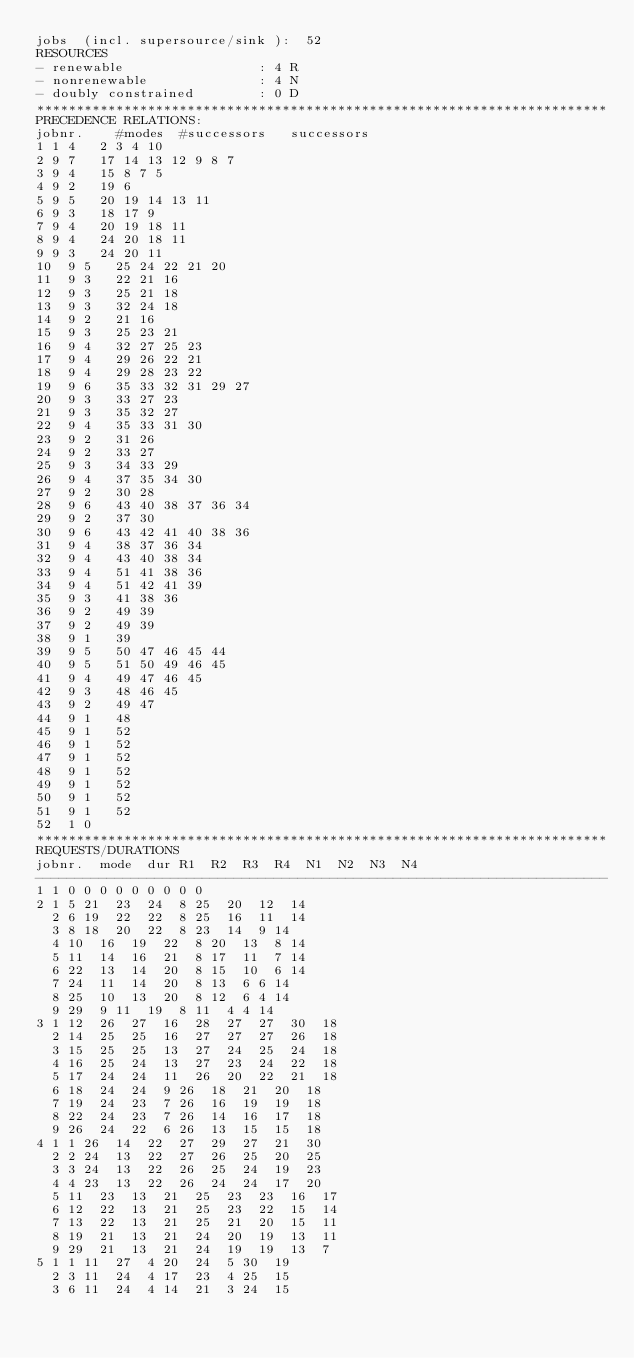Convert code to text. <code><loc_0><loc_0><loc_500><loc_500><_ObjectiveC_>jobs  (incl. supersource/sink ):	52
RESOURCES
- renewable                 : 4 R
- nonrenewable              : 4 N
- doubly constrained        : 0 D
************************************************************************
PRECEDENCE RELATIONS:
jobnr.    #modes  #successors   successors
1	1	4		2 3 4 10 
2	9	7		17 14 13 12 9 8 7 
3	9	4		15 8 7 5 
4	9	2		19 6 
5	9	5		20 19 14 13 11 
6	9	3		18 17 9 
7	9	4		20 19 18 11 
8	9	4		24 20 18 11 
9	9	3		24 20 11 
10	9	5		25 24 22 21 20 
11	9	3		22 21 16 
12	9	3		25 21 18 
13	9	3		32 24 18 
14	9	2		21 16 
15	9	3		25 23 21 
16	9	4		32 27 25 23 
17	9	4		29 26 22 21 
18	9	4		29 28 23 22 
19	9	6		35 33 32 31 29 27 
20	9	3		33 27 23 
21	9	3		35 32 27 
22	9	4		35 33 31 30 
23	9	2		31 26 
24	9	2		33 27 
25	9	3		34 33 29 
26	9	4		37 35 34 30 
27	9	2		30 28 
28	9	6		43 40 38 37 36 34 
29	9	2		37 30 
30	9	6		43 42 41 40 38 36 
31	9	4		38 37 36 34 
32	9	4		43 40 38 34 
33	9	4		51 41 38 36 
34	9	4		51 42 41 39 
35	9	3		41 38 36 
36	9	2		49 39 
37	9	2		49 39 
38	9	1		39 
39	9	5		50 47 46 45 44 
40	9	5		51 50 49 46 45 
41	9	4		49 47 46 45 
42	9	3		48 46 45 
43	9	2		49 47 
44	9	1		48 
45	9	1		52 
46	9	1		52 
47	9	1		52 
48	9	1		52 
49	9	1		52 
50	9	1		52 
51	9	1		52 
52	1	0		
************************************************************************
REQUESTS/DURATIONS
jobnr.	mode	dur	R1	R2	R3	R4	N1	N2	N3	N4	
------------------------------------------------------------------------
1	1	0	0	0	0	0	0	0	0	0	
2	1	5	21	23	24	8	25	20	12	14	
	2	6	19	22	22	8	25	16	11	14	
	3	8	18	20	22	8	23	14	9	14	
	4	10	16	19	22	8	20	13	8	14	
	5	11	14	16	21	8	17	11	7	14	
	6	22	13	14	20	8	15	10	6	14	
	7	24	11	14	20	8	13	6	6	14	
	8	25	10	13	20	8	12	6	4	14	
	9	29	9	11	19	8	11	4	4	14	
3	1	12	26	27	16	28	27	27	30	18	
	2	14	25	25	16	27	27	27	26	18	
	3	15	25	25	13	27	24	25	24	18	
	4	16	25	24	13	27	23	24	22	18	
	5	17	24	24	11	26	20	22	21	18	
	6	18	24	24	9	26	18	21	20	18	
	7	19	24	23	7	26	16	19	19	18	
	8	22	24	23	7	26	14	16	17	18	
	9	26	24	22	6	26	13	15	15	18	
4	1	1	26	14	22	27	29	27	21	30	
	2	2	24	13	22	27	26	25	20	25	
	3	3	24	13	22	26	25	24	19	23	
	4	4	23	13	22	26	24	24	17	20	
	5	11	23	13	21	25	23	23	16	17	
	6	12	22	13	21	25	23	22	15	14	
	7	13	22	13	21	25	21	20	15	11	
	8	19	21	13	21	24	20	19	13	11	
	9	29	21	13	21	24	19	19	13	7	
5	1	1	11	27	4	20	24	5	30	19	
	2	3	11	24	4	17	23	4	25	15	
	3	6	11	24	4	14	21	3	24	15	</code> 